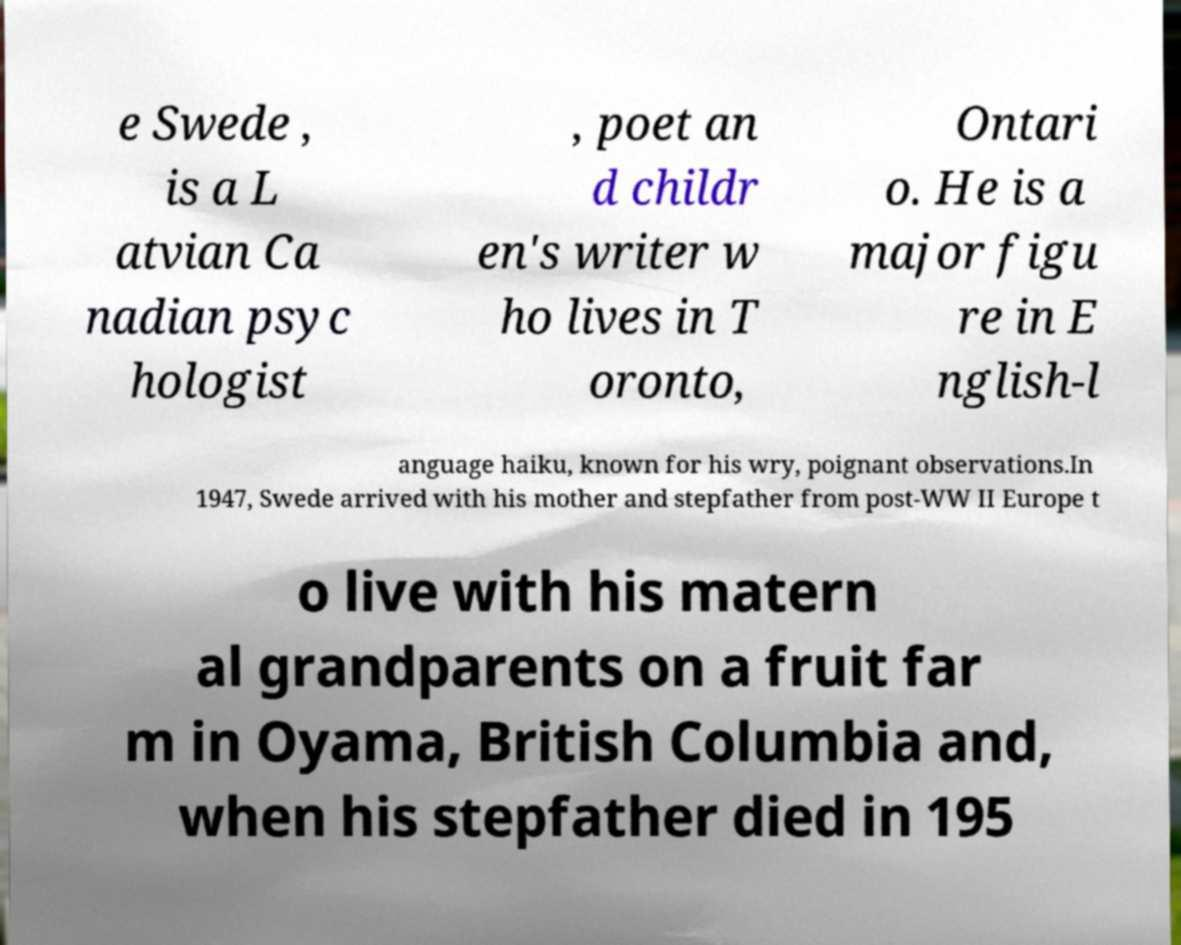Could you assist in decoding the text presented in this image and type it out clearly? e Swede , is a L atvian Ca nadian psyc hologist , poet an d childr en's writer w ho lives in T oronto, Ontari o. He is a major figu re in E nglish-l anguage haiku, known for his wry, poignant observations.In 1947, Swede arrived with his mother and stepfather from post-WW II Europe t o live with his matern al grandparents on a fruit far m in Oyama, British Columbia and, when his stepfather died in 195 